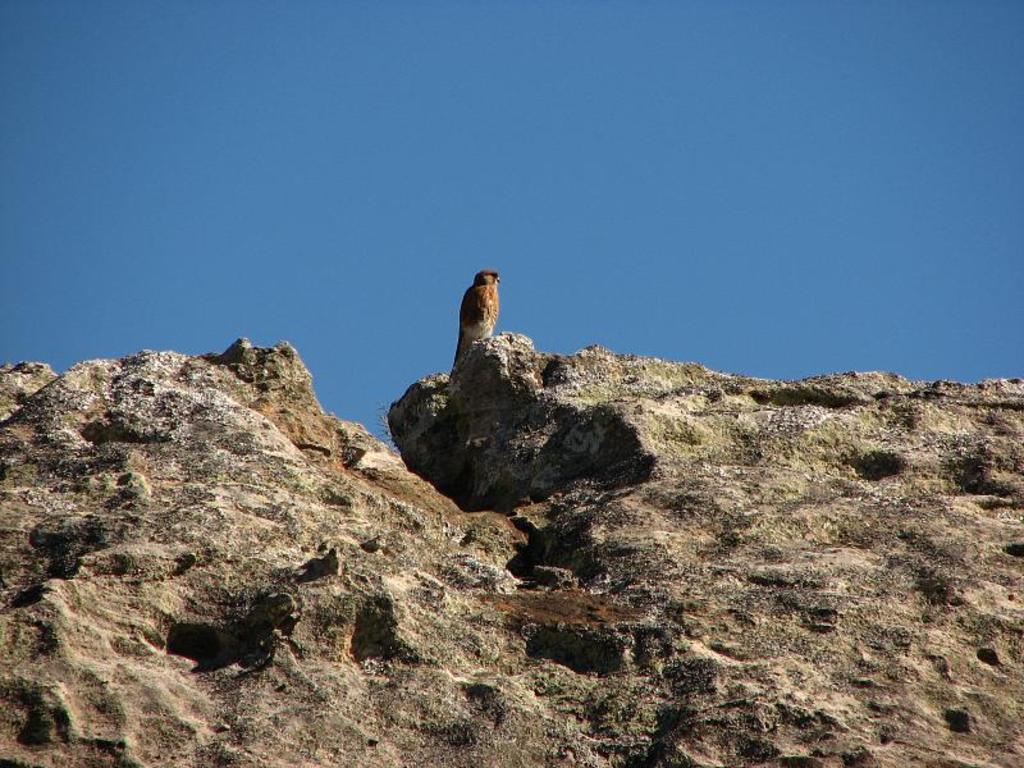How would you summarize this image in a sentence or two? In the center of the image we can see a bird on the rock. In the background there is sky. 